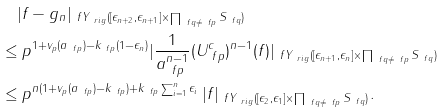<formula> <loc_0><loc_0><loc_500><loc_500>& \quad | f - g _ { n } | _ { \ f Y _ { \ r i g } ( [ \epsilon _ { n + 2 } , \epsilon _ { n + 1 } ] \times \prod _ { \ f q \neq \ f p } S _ { \ f q } ) } \\ & \leq p ^ { 1 + v _ { p } ( a _ { \ f p } ) - k _ { \ f p } ( 1 - \epsilon _ { n } ) } | \frac { 1 } { a _ { \ f p } ^ { n - 1 } } ( U _ { \ f p } ^ { c } ) ^ { n - 1 } ( f ) | _ { \ f Y _ { \ r i g } ( [ \epsilon _ { n + 1 } , \epsilon _ { n } ] \times \prod _ { \ f q \neq \ f p } S _ { \ f q } ) } \\ & \leq p ^ { n ( 1 + v _ { p } ( a _ { \ f p } ) - k _ { \ f p } ) + k _ { \ f p } \sum _ { i = 1 } ^ { n } \epsilon _ { i } } \, | f | _ { \ f Y _ { \ r i g } ( [ \epsilon _ { 2 } , \epsilon _ { 1 } ] \times \prod _ { \ f q \neq \ f p } S _ { \ f q } ) } .</formula> 